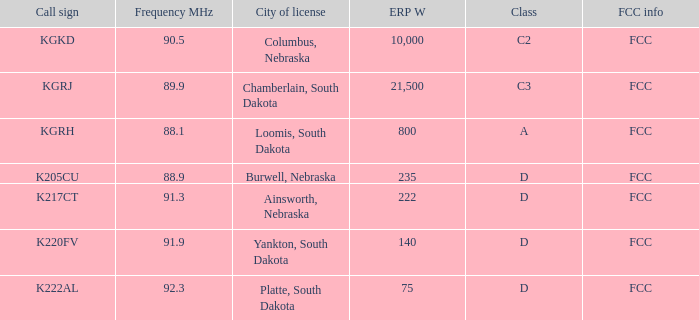What is the total erp w of class c3, which has a frequency mhz less than 89.9? 0.0. 